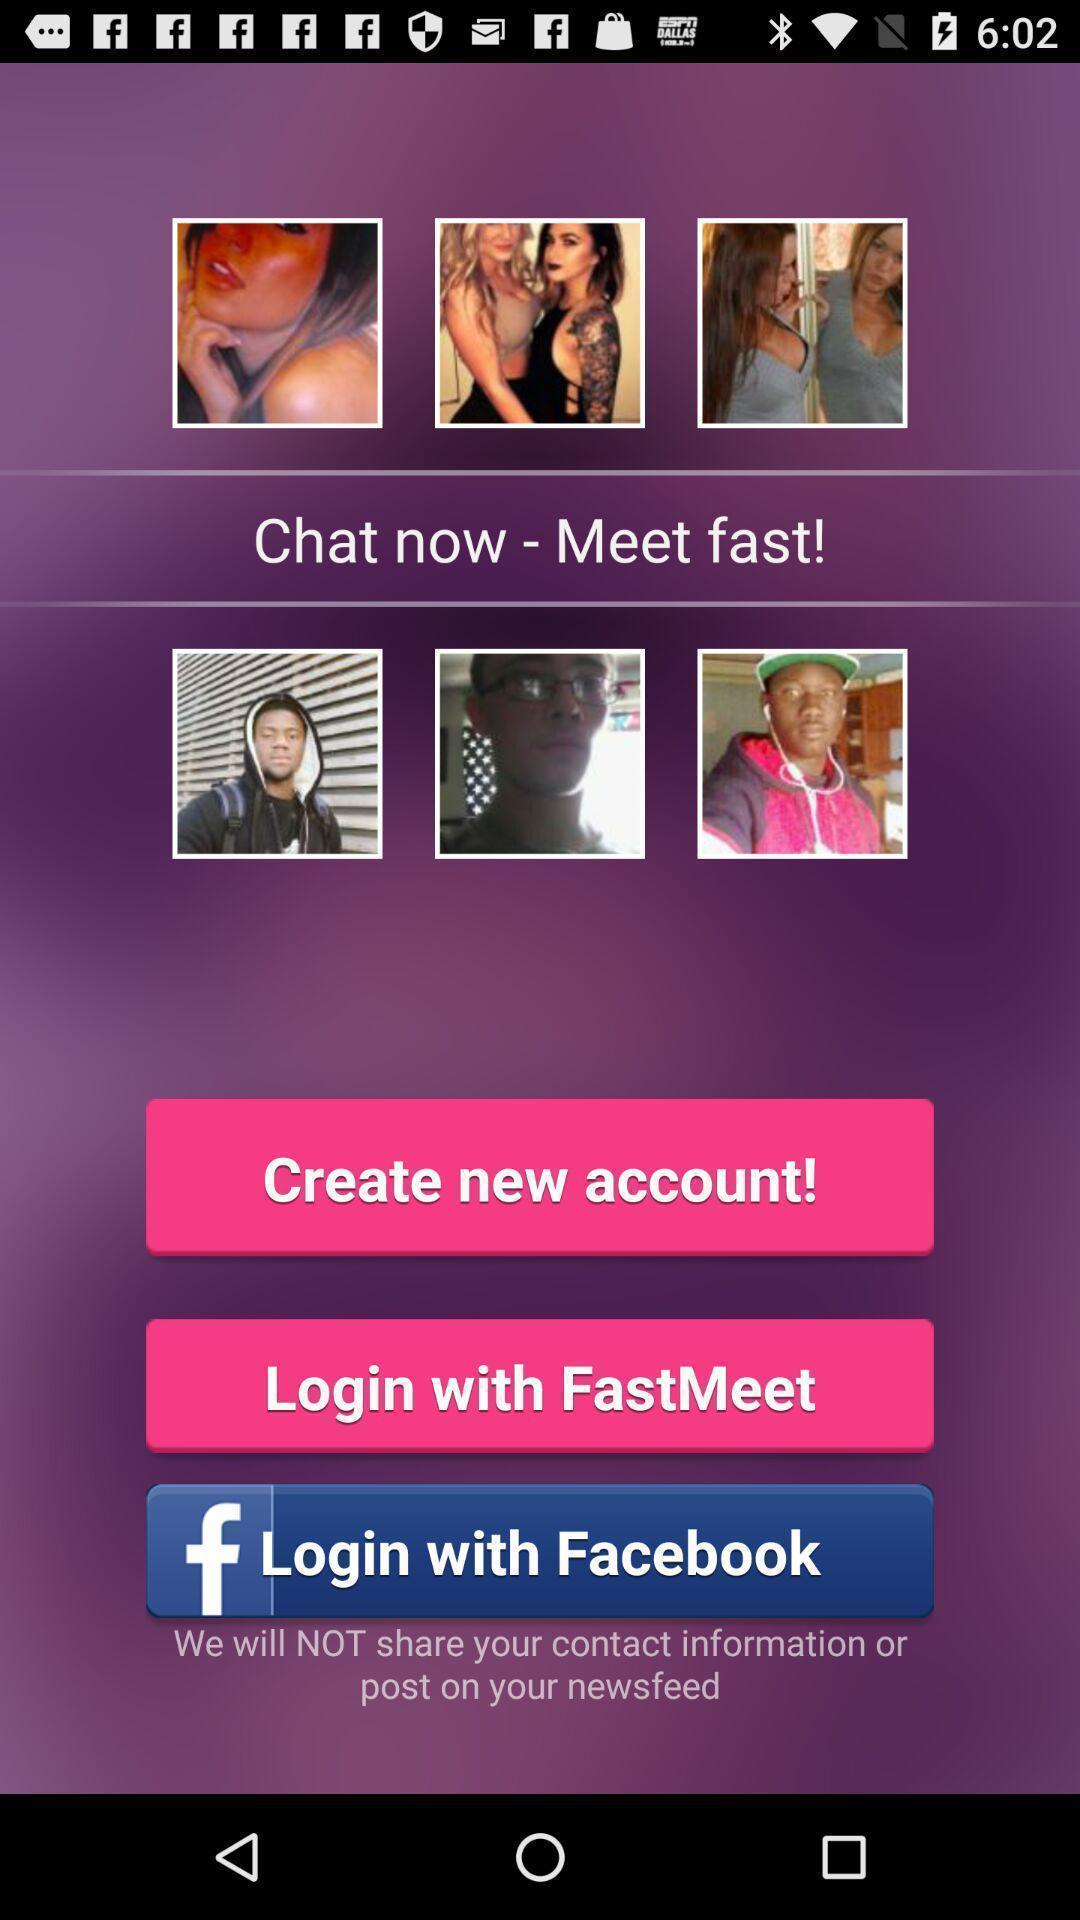Provide a description of this screenshot. Page showing login page. 